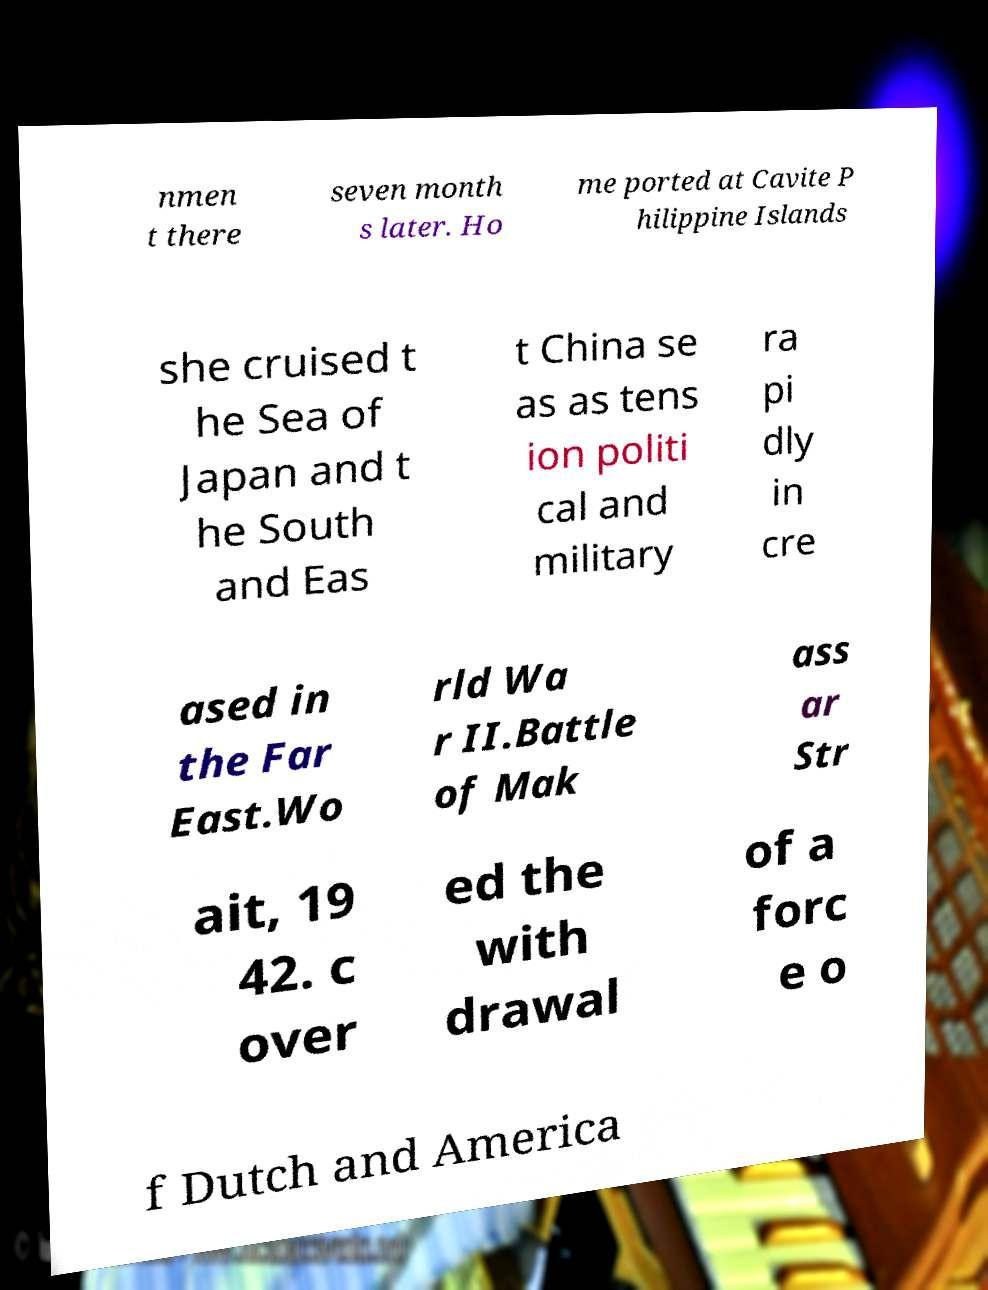Can you read and provide the text displayed in the image?This photo seems to have some interesting text. Can you extract and type it out for me? nmen t there seven month s later. Ho me ported at Cavite P hilippine Islands she cruised t he Sea of Japan and t he South and Eas t China se as as tens ion politi cal and military ra pi dly in cre ased in the Far East.Wo rld Wa r II.Battle of Mak ass ar Str ait, 19 42. c over ed the with drawal of a forc e o f Dutch and America 